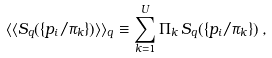<formula> <loc_0><loc_0><loc_500><loc_500>\langle \langle S _ { q } ( \{ p _ { i } / \pi _ { k } \} ) \rangle \rangle _ { q } \equiv \sum _ { k = 1 } ^ { U } \Pi _ { k } \, S _ { q } ( \{ p _ { i } / \pi _ { k } \} ) \, ,</formula> 